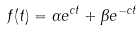Convert formula to latex. <formula><loc_0><loc_0><loc_500><loc_500>f ( t ) = { \alpha } e ^ { c t } + { \beta } e ^ { - c t }</formula> 